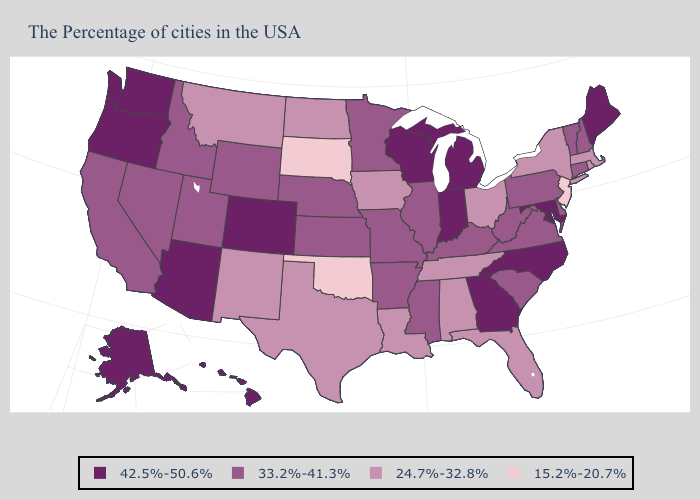Does New Jersey have the lowest value in the USA?
Quick response, please. Yes. Name the states that have a value in the range 15.2%-20.7%?
Give a very brief answer. New Jersey, Oklahoma, South Dakota. What is the value of Tennessee?
Be succinct. 24.7%-32.8%. Does Montana have the lowest value in the West?
Keep it brief. Yes. Does Oklahoma have the lowest value in the USA?
Answer briefly. Yes. Name the states that have a value in the range 33.2%-41.3%?
Short answer required. New Hampshire, Vermont, Connecticut, Delaware, Pennsylvania, Virginia, South Carolina, West Virginia, Kentucky, Illinois, Mississippi, Missouri, Arkansas, Minnesota, Kansas, Nebraska, Wyoming, Utah, Idaho, Nevada, California. Does Hawaii have the highest value in the USA?
Quick response, please. Yes. What is the value of Oklahoma?
Keep it brief. 15.2%-20.7%. What is the value of Michigan?
Give a very brief answer. 42.5%-50.6%. Name the states that have a value in the range 24.7%-32.8%?
Write a very short answer. Massachusetts, Rhode Island, New York, Ohio, Florida, Alabama, Tennessee, Louisiana, Iowa, Texas, North Dakota, New Mexico, Montana. What is the highest value in the USA?
Keep it brief. 42.5%-50.6%. What is the value of Virginia?
Be succinct. 33.2%-41.3%. What is the lowest value in the USA?
Give a very brief answer. 15.2%-20.7%. Among the states that border North Dakota , does South Dakota have the lowest value?
Answer briefly. Yes. What is the value of Vermont?
Keep it brief. 33.2%-41.3%. 